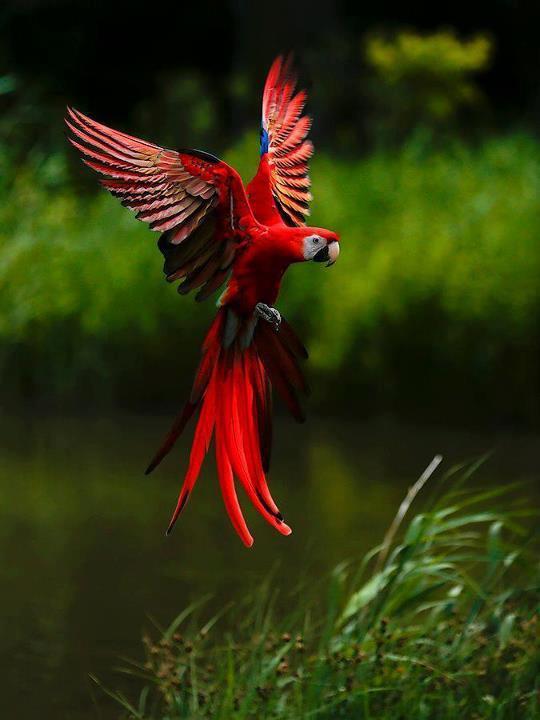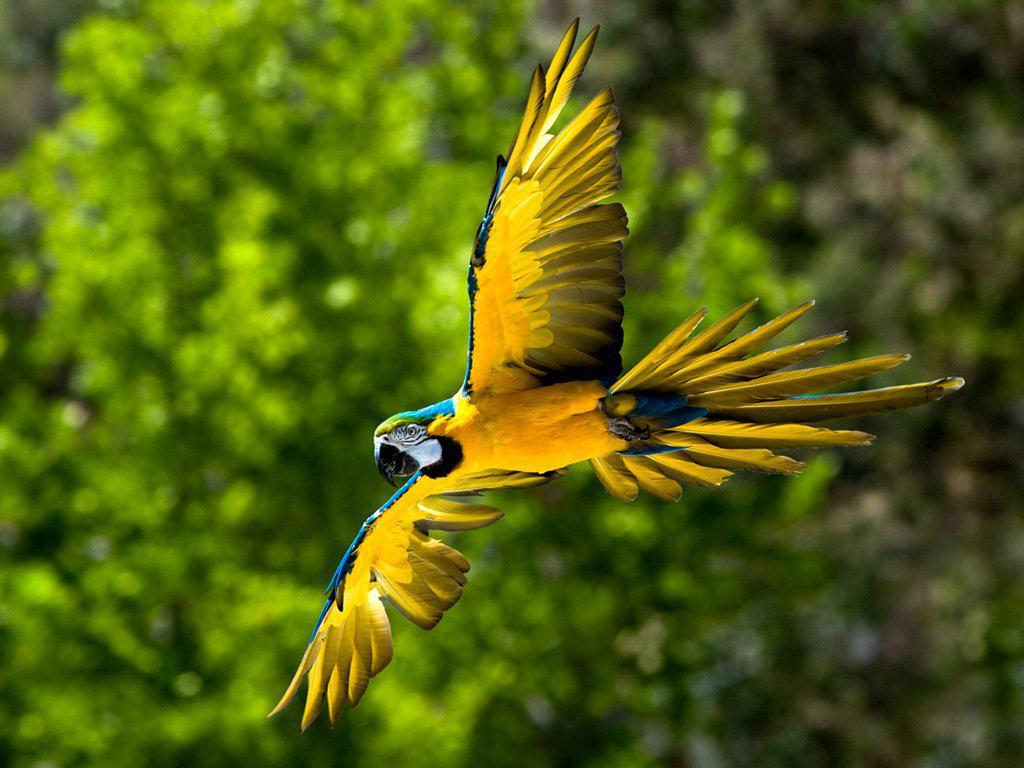The first image is the image on the left, the second image is the image on the right. Analyze the images presented: Is the assertion "The parrot in the right image is flying." valid? Answer yes or no. Yes. The first image is the image on the left, the second image is the image on the right. Analyze the images presented: Is the assertion "At least one of the images has two birds standing on the same branch." valid? Answer yes or no. No. 